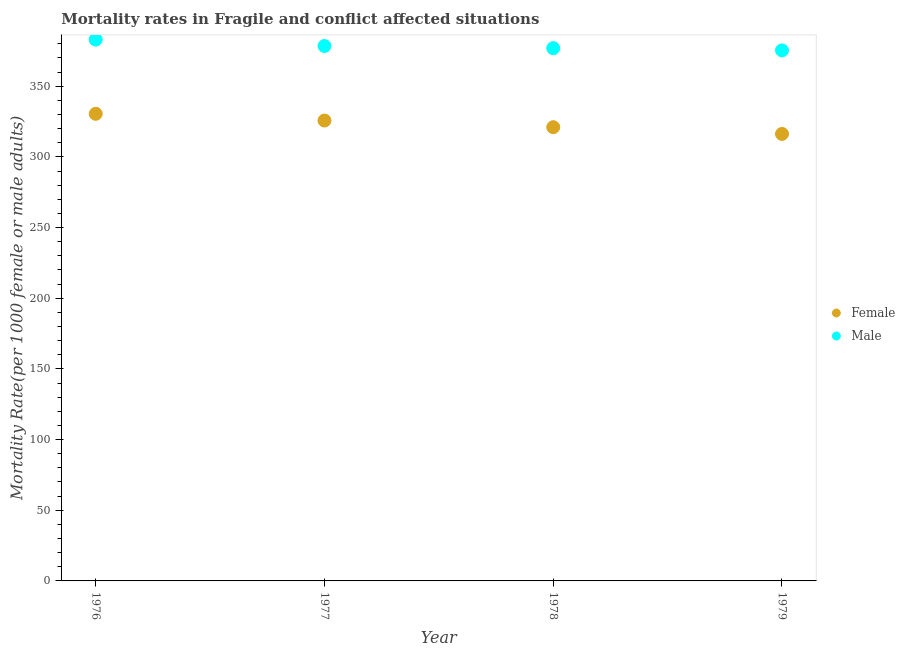How many different coloured dotlines are there?
Give a very brief answer. 2. What is the female mortality rate in 1979?
Make the answer very short. 316.25. Across all years, what is the maximum female mortality rate?
Make the answer very short. 330.49. Across all years, what is the minimum female mortality rate?
Your answer should be very brief. 316.25. In which year was the female mortality rate maximum?
Provide a short and direct response. 1976. In which year was the female mortality rate minimum?
Ensure brevity in your answer.  1979. What is the total female mortality rate in the graph?
Your answer should be very brief. 1293.46. What is the difference between the female mortality rate in 1978 and that in 1979?
Offer a terse response. 4.76. What is the difference between the male mortality rate in 1979 and the female mortality rate in 1977?
Offer a terse response. 49.65. What is the average female mortality rate per year?
Ensure brevity in your answer.  323.37. In the year 1979, what is the difference between the male mortality rate and female mortality rate?
Your answer should be compact. 59.11. What is the ratio of the female mortality rate in 1977 to that in 1978?
Make the answer very short. 1.01. Is the difference between the female mortality rate in 1976 and 1978 greater than the difference between the male mortality rate in 1976 and 1978?
Provide a short and direct response. Yes. What is the difference between the highest and the second highest female mortality rate?
Make the answer very short. 4.78. What is the difference between the highest and the lowest male mortality rate?
Your answer should be compact. 7.63. Is the sum of the male mortality rate in 1976 and 1977 greater than the maximum female mortality rate across all years?
Your answer should be compact. Yes. Does the female mortality rate monotonically increase over the years?
Your answer should be compact. No. Is the female mortality rate strictly greater than the male mortality rate over the years?
Keep it short and to the point. No. Is the male mortality rate strictly less than the female mortality rate over the years?
Offer a terse response. No. How many dotlines are there?
Your answer should be very brief. 2. How many years are there in the graph?
Offer a terse response. 4. Are the values on the major ticks of Y-axis written in scientific E-notation?
Provide a succinct answer. No. Does the graph contain grids?
Your response must be concise. No. Where does the legend appear in the graph?
Ensure brevity in your answer.  Center right. What is the title of the graph?
Your answer should be very brief. Mortality rates in Fragile and conflict affected situations. Does "Non-resident workers" appear as one of the legend labels in the graph?
Offer a very short reply. No. What is the label or title of the X-axis?
Make the answer very short. Year. What is the label or title of the Y-axis?
Give a very brief answer. Mortality Rate(per 1000 female or male adults). What is the Mortality Rate(per 1000 female or male adults) of Female in 1976?
Provide a succinct answer. 330.49. What is the Mortality Rate(per 1000 female or male adults) in Male in 1976?
Make the answer very short. 382.99. What is the Mortality Rate(per 1000 female or male adults) in Female in 1977?
Provide a succinct answer. 325.71. What is the Mortality Rate(per 1000 female or male adults) of Male in 1977?
Give a very brief answer. 378.46. What is the Mortality Rate(per 1000 female or male adults) of Female in 1978?
Provide a succinct answer. 321.01. What is the Mortality Rate(per 1000 female or male adults) of Male in 1978?
Keep it short and to the point. 376.93. What is the Mortality Rate(per 1000 female or male adults) in Female in 1979?
Make the answer very short. 316.25. What is the Mortality Rate(per 1000 female or male adults) of Male in 1979?
Give a very brief answer. 375.36. Across all years, what is the maximum Mortality Rate(per 1000 female or male adults) in Female?
Your response must be concise. 330.49. Across all years, what is the maximum Mortality Rate(per 1000 female or male adults) of Male?
Keep it short and to the point. 382.99. Across all years, what is the minimum Mortality Rate(per 1000 female or male adults) in Female?
Offer a very short reply. 316.25. Across all years, what is the minimum Mortality Rate(per 1000 female or male adults) of Male?
Offer a terse response. 375.36. What is the total Mortality Rate(per 1000 female or male adults) of Female in the graph?
Ensure brevity in your answer.  1293.46. What is the total Mortality Rate(per 1000 female or male adults) in Male in the graph?
Ensure brevity in your answer.  1513.75. What is the difference between the Mortality Rate(per 1000 female or male adults) in Female in 1976 and that in 1977?
Provide a short and direct response. 4.78. What is the difference between the Mortality Rate(per 1000 female or male adults) of Male in 1976 and that in 1977?
Offer a terse response. 4.53. What is the difference between the Mortality Rate(per 1000 female or male adults) of Female in 1976 and that in 1978?
Offer a very short reply. 9.48. What is the difference between the Mortality Rate(per 1000 female or male adults) in Male in 1976 and that in 1978?
Give a very brief answer. 6.06. What is the difference between the Mortality Rate(per 1000 female or male adults) in Female in 1976 and that in 1979?
Offer a very short reply. 14.24. What is the difference between the Mortality Rate(per 1000 female or male adults) of Male in 1976 and that in 1979?
Provide a succinct answer. 7.63. What is the difference between the Mortality Rate(per 1000 female or male adults) in Female in 1977 and that in 1978?
Make the answer very short. 4.7. What is the difference between the Mortality Rate(per 1000 female or male adults) of Male in 1977 and that in 1978?
Provide a succinct answer. 1.53. What is the difference between the Mortality Rate(per 1000 female or male adults) in Female in 1977 and that in 1979?
Give a very brief answer. 9.46. What is the difference between the Mortality Rate(per 1000 female or male adults) in Male in 1977 and that in 1979?
Your answer should be compact. 3.1. What is the difference between the Mortality Rate(per 1000 female or male adults) of Female in 1978 and that in 1979?
Provide a short and direct response. 4.76. What is the difference between the Mortality Rate(per 1000 female or male adults) in Male in 1978 and that in 1979?
Offer a very short reply. 1.57. What is the difference between the Mortality Rate(per 1000 female or male adults) of Female in 1976 and the Mortality Rate(per 1000 female or male adults) of Male in 1977?
Provide a succinct answer. -47.97. What is the difference between the Mortality Rate(per 1000 female or male adults) of Female in 1976 and the Mortality Rate(per 1000 female or male adults) of Male in 1978?
Your response must be concise. -46.44. What is the difference between the Mortality Rate(per 1000 female or male adults) in Female in 1976 and the Mortality Rate(per 1000 female or male adults) in Male in 1979?
Give a very brief answer. -44.87. What is the difference between the Mortality Rate(per 1000 female or male adults) of Female in 1977 and the Mortality Rate(per 1000 female or male adults) of Male in 1978?
Provide a short and direct response. -51.22. What is the difference between the Mortality Rate(per 1000 female or male adults) in Female in 1977 and the Mortality Rate(per 1000 female or male adults) in Male in 1979?
Provide a short and direct response. -49.65. What is the difference between the Mortality Rate(per 1000 female or male adults) of Female in 1978 and the Mortality Rate(per 1000 female or male adults) of Male in 1979?
Provide a succinct answer. -54.35. What is the average Mortality Rate(per 1000 female or male adults) in Female per year?
Your answer should be very brief. 323.37. What is the average Mortality Rate(per 1000 female or male adults) in Male per year?
Provide a succinct answer. 378.44. In the year 1976, what is the difference between the Mortality Rate(per 1000 female or male adults) in Female and Mortality Rate(per 1000 female or male adults) in Male?
Your answer should be very brief. -52.5. In the year 1977, what is the difference between the Mortality Rate(per 1000 female or male adults) in Female and Mortality Rate(per 1000 female or male adults) in Male?
Your response must be concise. -52.75. In the year 1978, what is the difference between the Mortality Rate(per 1000 female or male adults) of Female and Mortality Rate(per 1000 female or male adults) of Male?
Offer a very short reply. -55.92. In the year 1979, what is the difference between the Mortality Rate(per 1000 female or male adults) of Female and Mortality Rate(per 1000 female or male adults) of Male?
Provide a short and direct response. -59.11. What is the ratio of the Mortality Rate(per 1000 female or male adults) in Female in 1976 to that in 1977?
Provide a short and direct response. 1.01. What is the ratio of the Mortality Rate(per 1000 female or male adults) in Male in 1976 to that in 1977?
Ensure brevity in your answer.  1.01. What is the ratio of the Mortality Rate(per 1000 female or male adults) of Female in 1976 to that in 1978?
Offer a very short reply. 1.03. What is the ratio of the Mortality Rate(per 1000 female or male adults) in Male in 1976 to that in 1978?
Provide a short and direct response. 1.02. What is the ratio of the Mortality Rate(per 1000 female or male adults) in Female in 1976 to that in 1979?
Your answer should be compact. 1.04. What is the ratio of the Mortality Rate(per 1000 female or male adults) of Male in 1976 to that in 1979?
Make the answer very short. 1.02. What is the ratio of the Mortality Rate(per 1000 female or male adults) of Female in 1977 to that in 1978?
Ensure brevity in your answer.  1.01. What is the ratio of the Mortality Rate(per 1000 female or male adults) of Male in 1977 to that in 1978?
Offer a terse response. 1. What is the ratio of the Mortality Rate(per 1000 female or male adults) of Female in 1977 to that in 1979?
Give a very brief answer. 1.03. What is the ratio of the Mortality Rate(per 1000 female or male adults) of Male in 1977 to that in 1979?
Ensure brevity in your answer.  1.01. What is the difference between the highest and the second highest Mortality Rate(per 1000 female or male adults) of Female?
Offer a terse response. 4.78. What is the difference between the highest and the second highest Mortality Rate(per 1000 female or male adults) in Male?
Ensure brevity in your answer.  4.53. What is the difference between the highest and the lowest Mortality Rate(per 1000 female or male adults) in Female?
Make the answer very short. 14.24. What is the difference between the highest and the lowest Mortality Rate(per 1000 female or male adults) of Male?
Keep it short and to the point. 7.63. 